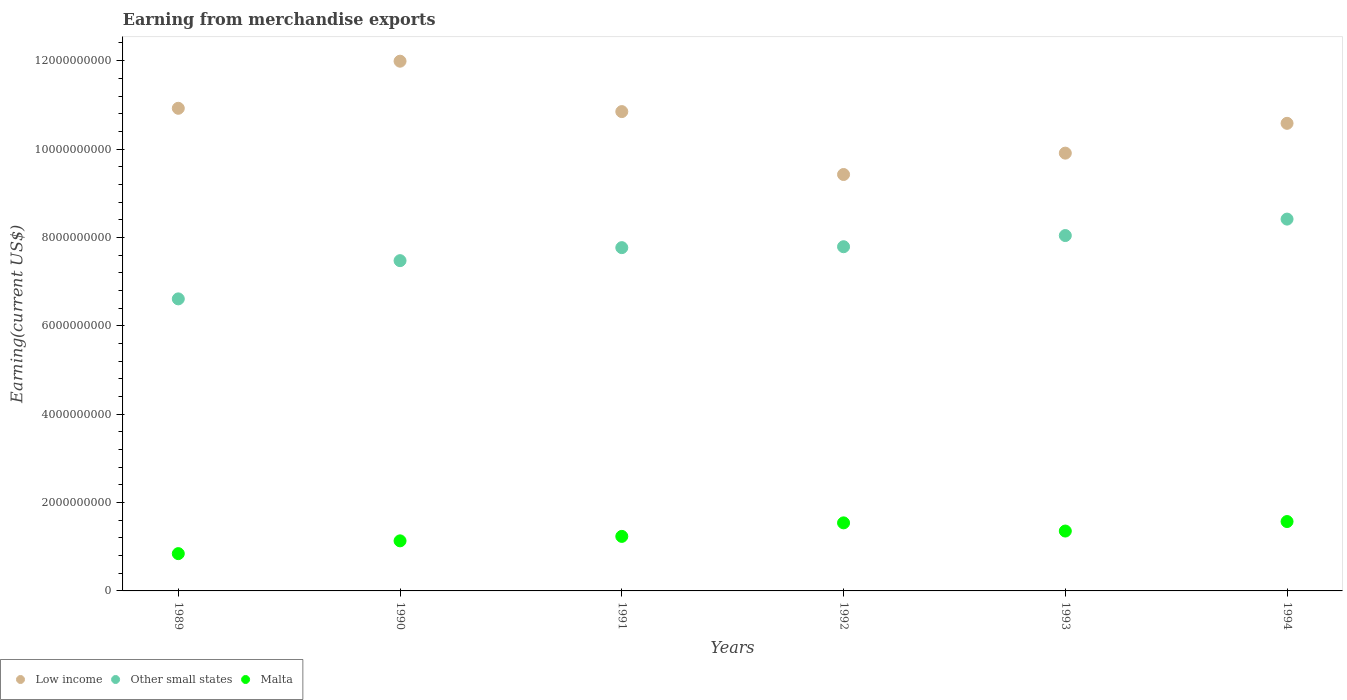How many different coloured dotlines are there?
Ensure brevity in your answer.  3. Is the number of dotlines equal to the number of legend labels?
Ensure brevity in your answer.  Yes. What is the amount earned from merchandise exports in Malta in 1989?
Offer a very short reply. 8.44e+08. Across all years, what is the maximum amount earned from merchandise exports in Low income?
Keep it short and to the point. 1.20e+1. Across all years, what is the minimum amount earned from merchandise exports in Malta?
Offer a terse response. 8.44e+08. In which year was the amount earned from merchandise exports in Malta maximum?
Your response must be concise. 1994. What is the total amount earned from merchandise exports in Malta in the graph?
Provide a succinct answer. 7.68e+09. What is the difference between the amount earned from merchandise exports in Low income in 1989 and that in 1994?
Your answer should be very brief. 3.40e+08. What is the difference between the amount earned from merchandise exports in Malta in 1991 and the amount earned from merchandise exports in Low income in 1992?
Offer a terse response. -8.19e+09. What is the average amount earned from merchandise exports in Other small states per year?
Give a very brief answer. 7.68e+09. In the year 1989, what is the difference between the amount earned from merchandise exports in Malta and amount earned from merchandise exports in Low income?
Give a very brief answer. -1.01e+1. What is the ratio of the amount earned from merchandise exports in Malta in 1992 to that in 1993?
Ensure brevity in your answer.  1.14. What is the difference between the highest and the second highest amount earned from merchandise exports in Malta?
Ensure brevity in your answer.  3.00e+07. What is the difference between the highest and the lowest amount earned from merchandise exports in Other small states?
Your response must be concise. 1.81e+09. Is it the case that in every year, the sum of the amount earned from merchandise exports in Malta and amount earned from merchandise exports in Other small states  is greater than the amount earned from merchandise exports in Low income?
Provide a succinct answer. No. Does the amount earned from merchandise exports in Other small states monotonically increase over the years?
Offer a very short reply. Yes. How many years are there in the graph?
Make the answer very short. 6. What is the difference between two consecutive major ticks on the Y-axis?
Provide a succinct answer. 2.00e+09. Does the graph contain any zero values?
Your response must be concise. No. Where does the legend appear in the graph?
Give a very brief answer. Bottom left. How many legend labels are there?
Make the answer very short. 3. What is the title of the graph?
Offer a very short reply. Earning from merchandise exports. What is the label or title of the X-axis?
Provide a short and direct response. Years. What is the label or title of the Y-axis?
Keep it short and to the point. Earning(current US$). What is the Earning(current US$) of Low income in 1989?
Your response must be concise. 1.09e+1. What is the Earning(current US$) in Other small states in 1989?
Your answer should be compact. 6.61e+09. What is the Earning(current US$) in Malta in 1989?
Make the answer very short. 8.44e+08. What is the Earning(current US$) of Low income in 1990?
Offer a terse response. 1.20e+1. What is the Earning(current US$) of Other small states in 1990?
Give a very brief answer. 7.47e+09. What is the Earning(current US$) of Malta in 1990?
Your answer should be compact. 1.13e+09. What is the Earning(current US$) in Low income in 1991?
Your answer should be compact. 1.08e+1. What is the Earning(current US$) of Other small states in 1991?
Provide a succinct answer. 7.77e+09. What is the Earning(current US$) of Malta in 1991?
Offer a very short reply. 1.23e+09. What is the Earning(current US$) in Low income in 1992?
Your answer should be compact. 9.42e+09. What is the Earning(current US$) in Other small states in 1992?
Offer a terse response. 7.79e+09. What is the Earning(current US$) in Malta in 1992?
Ensure brevity in your answer.  1.54e+09. What is the Earning(current US$) of Low income in 1993?
Your answer should be very brief. 9.91e+09. What is the Earning(current US$) in Other small states in 1993?
Your answer should be very brief. 8.04e+09. What is the Earning(current US$) in Malta in 1993?
Provide a short and direct response. 1.36e+09. What is the Earning(current US$) in Low income in 1994?
Your answer should be very brief. 1.06e+1. What is the Earning(current US$) of Other small states in 1994?
Offer a terse response. 8.41e+09. What is the Earning(current US$) of Malta in 1994?
Make the answer very short. 1.57e+09. Across all years, what is the maximum Earning(current US$) in Low income?
Offer a very short reply. 1.20e+1. Across all years, what is the maximum Earning(current US$) in Other small states?
Offer a terse response. 8.41e+09. Across all years, what is the maximum Earning(current US$) of Malta?
Offer a terse response. 1.57e+09. Across all years, what is the minimum Earning(current US$) of Low income?
Offer a very short reply. 9.42e+09. Across all years, what is the minimum Earning(current US$) of Other small states?
Provide a short and direct response. 6.61e+09. Across all years, what is the minimum Earning(current US$) of Malta?
Provide a short and direct response. 8.44e+08. What is the total Earning(current US$) in Low income in the graph?
Offer a very short reply. 6.37e+1. What is the total Earning(current US$) of Other small states in the graph?
Offer a terse response. 4.61e+1. What is the total Earning(current US$) in Malta in the graph?
Ensure brevity in your answer.  7.68e+09. What is the difference between the Earning(current US$) of Low income in 1989 and that in 1990?
Ensure brevity in your answer.  -1.07e+09. What is the difference between the Earning(current US$) of Other small states in 1989 and that in 1990?
Your answer should be compact. -8.65e+08. What is the difference between the Earning(current US$) in Malta in 1989 and that in 1990?
Provide a succinct answer. -2.89e+08. What is the difference between the Earning(current US$) in Low income in 1989 and that in 1991?
Offer a terse response. 7.49e+07. What is the difference between the Earning(current US$) of Other small states in 1989 and that in 1991?
Offer a terse response. -1.16e+09. What is the difference between the Earning(current US$) in Malta in 1989 and that in 1991?
Your response must be concise. -3.90e+08. What is the difference between the Earning(current US$) of Low income in 1989 and that in 1992?
Ensure brevity in your answer.  1.50e+09. What is the difference between the Earning(current US$) in Other small states in 1989 and that in 1992?
Offer a very short reply. -1.18e+09. What is the difference between the Earning(current US$) in Malta in 1989 and that in 1992?
Your answer should be very brief. -6.96e+08. What is the difference between the Earning(current US$) in Low income in 1989 and that in 1993?
Your answer should be compact. 1.01e+09. What is the difference between the Earning(current US$) in Other small states in 1989 and that in 1993?
Your response must be concise. -1.43e+09. What is the difference between the Earning(current US$) of Malta in 1989 and that in 1993?
Provide a succinct answer. -5.11e+08. What is the difference between the Earning(current US$) of Low income in 1989 and that in 1994?
Offer a very short reply. 3.40e+08. What is the difference between the Earning(current US$) in Other small states in 1989 and that in 1994?
Offer a terse response. -1.81e+09. What is the difference between the Earning(current US$) in Malta in 1989 and that in 1994?
Ensure brevity in your answer.  -7.26e+08. What is the difference between the Earning(current US$) of Low income in 1990 and that in 1991?
Provide a succinct answer. 1.14e+09. What is the difference between the Earning(current US$) in Other small states in 1990 and that in 1991?
Offer a very short reply. -2.94e+08. What is the difference between the Earning(current US$) in Malta in 1990 and that in 1991?
Provide a succinct answer. -1.01e+08. What is the difference between the Earning(current US$) of Low income in 1990 and that in 1992?
Your answer should be compact. 2.56e+09. What is the difference between the Earning(current US$) in Other small states in 1990 and that in 1992?
Your answer should be compact. -3.15e+08. What is the difference between the Earning(current US$) of Malta in 1990 and that in 1992?
Your answer should be very brief. -4.07e+08. What is the difference between the Earning(current US$) of Low income in 1990 and that in 1993?
Offer a very short reply. 2.08e+09. What is the difference between the Earning(current US$) in Other small states in 1990 and that in 1993?
Make the answer very short. -5.68e+08. What is the difference between the Earning(current US$) of Malta in 1990 and that in 1993?
Ensure brevity in your answer.  -2.22e+08. What is the difference between the Earning(current US$) in Low income in 1990 and that in 1994?
Make the answer very short. 1.41e+09. What is the difference between the Earning(current US$) in Other small states in 1990 and that in 1994?
Provide a succinct answer. -9.40e+08. What is the difference between the Earning(current US$) of Malta in 1990 and that in 1994?
Provide a short and direct response. -4.37e+08. What is the difference between the Earning(current US$) of Low income in 1991 and that in 1992?
Offer a very short reply. 1.42e+09. What is the difference between the Earning(current US$) of Other small states in 1991 and that in 1992?
Make the answer very short. -2.07e+07. What is the difference between the Earning(current US$) of Malta in 1991 and that in 1992?
Keep it short and to the point. -3.06e+08. What is the difference between the Earning(current US$) of Low income in 1991 and that in 1993?
Give a very brief answer. 9.40e+08. What is the difference between the Earning(current US$) of Other small states in 1991 and that in 1993?
Provide a short and direct response. -2.73e+08. What is the difference between the Earning(current US$) of Malta in 1991 and that in 1993?
Offer a very short reply. -1.21e+08. What is the difference between the Earning(current US$) in Low income in 1991 and that in 1994?
Provide a short and direct response. 2.65e+08. What is the difference between the Earning(current US$) of Other small states in 1991 and that in 1994?
Ensure brevity in your answer.  -6.46e+08. What is the difference between the Earning(current US$) in Malta in 1991 and that in 1994?
Provide a succinct answer. -3.36e+08. What is the difference between the Earning(current US$) in Low income in 1992 and that in 1993?
Provide a short and direct response. -4.84e+08. What is the difference between the Earning(current US$) in Other small states in 1992 and that in 1993?
Offer a terse response. -2.53e+08. What is the difference between the Earning(current US$) in Malta in 1992 and that in 1993?
Make the answer very short. 1.85e+08. What is the difference between the Earning(current US$) in Low income in 1992 and that in 1994?
Offer a terse response. -1.16e+09. What is the difference between the Earning(current US$) in Other small states in 1992 and that in 1994?
Keep it short and to the point. -6.25e+08. What is the difference between the Earning(current US$) in Malta in 1992 and that in 1994?
Offer a very short reply. -3.00e+07. What is the difference between the Earning(current US$) of Low income in 1993 and that in 1994?
Keep it short and to the point. -6.75e+08. What is the difference between the Earning(current US$) of Other small states in 1993 and that in 1994?
Provide a succinct answer. -3.72e+08. What is the difference between the Earning(current US$) in Malta in 1993 and that in 1994?
Offer a terse response. -2.15e+08. What is the difference between the Earning(current US$) in Low income in 1989 and the Earning(current US$) in Other small states in 1990?
Provide a succinct answer. 3.45e+09. What is the difference between the Earning(current US$) in Low income in 1989 and the Earning(current US$) in Malta in 1990?
Provide a short and direct response. 9.79e+09. What is the difference between the Earning(current US$) of Other small states in 1989 and the Earning(current US$) of Malta in 1990?
Give a very brief answer. 5.48e+09. What is the difference between the Earning(current US$) in Low income in 1989 and the Earning(current US$) in Other small states in 1991?
Provide a succinct answer. 3.15e+09. What is the difference between the Earning(current US$) in Low income in 1989 and the Earning(current US$) in Malta in 1991?
Offer a very short reply. 9.69e+09. What is the difference between the Earning(current US$) of Other small states in 1989 and the Earning(current US$) of Malta in 1991?
Make the answer very short. 5.38e+09. What is the difference between the Earning(current US$) in Low income in 1989 and the Earning(current US$) in Other small states in 1992?
Keep it short and to the point. 3.13e+09. What is the difference between the Earning(current US$) in Low income in 1989 and the Earning(current US$) in Malta in 1992?
Your response must be concise. 9.38e+09. What is the difference between the Earning(current US$) in Other small states in 1989 and the Earning(current US$) in Malta in 1992?
Give a very brief answer. 5.07e+09. What is the difference between the Earning(current US$) in Low income in 1989 and the Earning(current US$) in Other small states in 1993?
Provide a short and direct response. 2.88e+09. What is the difference between the Earning(current US$) in Low income in 1989 and the Earning(current US$) in Malta in 1993?
Provide a short and direct response. 9.57e+09. What is the difference between the Earning(current US$) in Other small states in 1989 and the Earning(current US$) in Malta in 1993?
Keep it short and to the point. 5.25e+09. What is the difference between the Earning(current US$) of Low income in 1989 and the Earning(current US$) of Other small states in 1994?
Your answer should be very brief. 2.51e+09. What is the difference between the Earning(current US$) in Low income in 1989 and the Earning(current US$) in Malta in 1994?
Your response must be concise. 9.35e+09. What is the difference between the Earning(current US$) in Other small states in 1989 and the Earning(current US$) in Malta in 1994?
Your response must be concise. 5.04e+09. What is the difference between the Earning(current US$) in Low income in 1990 and the Earning(current US$) in Other small states in 1991?
Your answer should be very brief. 4.22e+09. What is the difference between the Earning(current US$) of Low income in 1990 and the Earning(current US$) of Malta in 1991?
Provide a succinct answer. 1.08e+1. What is the difference between the Earning(current US$) in Other small states in 1990 and the Earning(current US$) in Malta in 1991?
Provide a short and direct response. 6.24e+09. What is the difference between the Earning(current US$) of Low income in 1990 and the Earning(current US$) of Other small states in 1992?
Your answer should be compact. 4.20e+09. What is the difference between the Earning(current US$) of Low income in 1990 and the Earning(current US$) of Malta in 1992?
Make the answer very short. 1.04e+1. What is the difference between the Earning(current US$) of Other small states in 1990 and the Earning(current US$) of Malta in 1992?
Your answer should be compact. 5.93e+09. What is the difference between the Earning(current US$) of Low income in 1990 and the Earning(current US$) of Other small states in 1993?
Your response must be concise. 3.95e+09. What is the difference between the Earning(current US$) of Low income in 1990 and the Earning(current US$) of Malta in 1993?
Your response must be concise. 1.06e+1. What is the difference between the Earning(current US$) in Other small states in 1990 and the Earning(current US$) in Malta in 1993?
Offer a terse response. 6.12e+09. What is the difference between the Earning(current US$) in Low income in 1990 and the Earning(current US$) in Other small states in 1994?
Keep it short and to the point. 3.57e+09. What is the difference between the Earning(current US$) of Low income in 1990 and the Earning(current US$) of Malta in 1994?
Offer a terse response. 1.04e+1. What is the difference between the Earning(current US$) in Other small states in 1990 and the Earning(current US$) in Malta in 1994?
Make the answer very short. 5.90e+09. What is the difference between the Earning(current US$) in Low income in 1991 and the Earning(current US$) in Other small states in 1992?
Offer a terse response. 3.06e+09. What is the difference between the Earning(current US$) in Low income in 1991 and the Earning(current US$) in Malta in 1992?
Provide a succinct answer. 9.31e+09. What is the difference between the Earning(current US$) in Other small states in 1991 and the Earning(current US$) in Malta in 1992?
Offer a terse response. 6.23e+09. What is the difference between the Earning(current US$) of Low income in 1991 and the Earning(current US$) of Other small states in 1993?
Offer a terse response. 2.81e+09. What is the difference between the Earning(current US$) of Low income in 1991 and the Earning(current US$) of Malta in 1993?
Provide a succinct answer. 9.49e+09. What is the difference between the Earning(current US$) of Other small states in 1991 and the Earning(current US$) of Malta in 1993?
Keep it short and to the point. 6.41e+09. What is the difference between the Earning(current US$) of Low income in 1991 and the Earning(current US$) of Other small states in 1994?
Offer a terse response. 2.43e+09. What is the difference between the Earning(current US$) in Low income in 1991 and the Earning(current US$) in Malta in 1994?
Keep it short and to the point. 9.28e+09. What is the difference between the Earning(current US$) in Other small states in 1991 and the Earning(current US$) in Malta in 1994?
Make the answer very short. 6.20e+09. What is the difference between the Earning(current US$) in Low income in 1992 and the Earning(current US$) in Other small states in 1993?
Offer a terse response. 1.38e+09. What is the difference between the Earning(current US$) in Low income in 1992 and the Earning(current US$) in Malta in 1993?
Make the answer very short. 8.07e+09. What is the difference between the Earning(current US$) of Other small states in 1992 and the Earning(current US$) of Malta in 1993?
Provide a succinct answer. 6.43e+09. What is the difference between the Earning(current US$) of Low income in 1992 and the Earning(current US$) of Other small states in 1994?
Provide a succinct answer. 1.01e+09. What is the difference between the Earning(current US$) in Low income in 1992 and the Earning(current US$) in Malta in 1994?
Make the answer very short. 7.85e+09. What is the difference between the Earning(current US$) of Other small states in 1992 and the Earning(current US$) of Malta in 1994?
Provide a succinct answer. 6.22e+09. What is the difference between the Earning(current US$) in Low income in 1993 and the Earning(current US$) in Other small states in 1994?
Keep it short and to the point. 1.49e+09. What is the difference between the Earning(current US$) in Low income in 1993 and the Earning(current US$) in Malta in 1994?
Keep it short and to the point. 8.34e+09. What is the difference between the Earning(current US$) in Other small states in 1993 and the Earning(current US$) in Malta in 1994?
Your answer should be very brief. 6.47e+09. What is the average Earning(current US$) in Low income per year?
Your response must be concise. 1.06e+1. What is the average Earning(current US$) of Other small states per year?
Make the answer very short. 7.68e+09. What is the average Earning(current US$) of Malta per year?
Keep it short and to the point. 1.28e+09. In the year 1989, what is the difference between the Earning(current US$) in Low income and Earning(current US$) in Other small states?
Your response must be concise. 4.31e+09. In the year 1989, what is the difference between the Earning(current US$) of Low income and Earning(current US$) of Malta?
Offer a very short reply. 1.01e+1. In the year 1989, what is the difference between the Earning(current US$) in Other small states and Earning(current US$) in Malta?
Offer a very short reply. 5.77e+09. In the year 1990, what is the difference between the Earning(current US$) in Low income and Earning(current US$) in Other small states?
Ensure brevity in your answer.  4.51e+09. In the year 1990, what is the difference between the Earning(current US$) of Low income and Earning(current US$) of Malta?
Give a very brief answer. 1.09e+1. In the year 1990, what is the difference between the Earning(current US$) of Other small states and Earning(current US$) of Malta?
Provide a succinct answer. 6.34e+09. In the year 1991, what is the difference between the Earning(current US$) in Low income and Earning(current US$) in Other small states?
Make the answer very short. 3.08e+09. In the year 1991, what is the difference between the Earning(current US$) of Low income and Earning(current US$) of Malta?
Ensure brevity in your answer.  9.61e+09. In the year 1991, what is the difference between the Earning(current US$) in Other small states and Earning(current US$) in Malta?
Make the answer very short. 6.53e+09. In the year 1992, what is the difference between the Earning(current US$) in Low income and Earning(current US$) in Other small states?
Your answer should be very brief. 1.63e+09. In the year 1992, what is the difference between the Earning(current US$) of Low income and Earning(current US$) of Malta?
Keep it short and to the point. 7.88e+09. In the year 1992, what is the difference between the Earning(current US$) in Other small states and Earning(current US$) in Malta?
Your answer should be compact. 6.25e+09. In the year 1993, what is the difference between the Earning(current US$) of Low income and Earning(current US$) of Other small states?
Offer a very short reply. 1.87e+09. In the year 1993, what is the difference between the Earning(current US$) in Low income and Earning(current US$) in Malta?
Your response must be concise. 8.55e+09. In the year 1993, what is the difference between the Earning(current US$) in Other small states and Earning(current US$) in Malta?
Give a very brief answer. 6.69e+09. In the year 1994, what is the difference between the Earning(current US$) of Low income and Earning(current US$) of Other small states?
Provide a short and direct response. 2.17e+09. In the year 1994, what is the difference between the Earning(current US$) in Low income and Earning(current US$) in Malta?
Provide a succinct answer. 9.01e+09. In the year 1994, what is the difference between the Earning(current US$) in Other small states and Earning(current US$) in Malta?
Offer a very short reply. 6.84e+09. What is the ratio of the Earning(current US$) of Low income in 1989 to that in 1990?
Your answer should be compact. 0.91. What is the ratio of the Earning(current US$) of Other small states in 1989 to that in 1990?
Your answer should be very brief. 0.88. What is the ratio of the Earning(current US$) of Malta in 1989 to that in 1990?
Your answer should be compact. 0.74. What is the ratio of the Earning(current US$) of Low income in 1989 to that in 1991?
Your answer should be very brief. 1.01. What is the ratio of the Earning(current US$) in Other small states in 1989 to that in 1991?
Your response must be concise. 0.85. What is the ratio of the Earning(current US$) in Malta in 1989 to that in 1991?
Your response must be concise. 0.68. What is the ratio of the Earning(current US$) of Low income in 1989 to that in 1992?
Your answer should be very brief. 1.16. What is the ratio of the Earning(current US$) of Other small states in 1989 to that in 1992?
Your response must be concise. 0.85. What is the ratio of the Earning(current US$) of Malta in 1989 to that in 1992?
Give a very brief answer. 0.55. What is the ratio of the Earning(current US$) of Low income in 1989 to that in 1993?
Ensure brevity in your answer.  1.1. What is the ratio of the Earning(current US$) in Other small states in 1989 to that in 1993?
Provide a succinct answer. 0.82. What is the ratio of the Earning(current US$) in Malta in 1989 to that in 1993?
Provide a short and direct response. 0.62. What is the ratio of the Earning(current US$) in Low income in 1989 to that in 1994?
Give a very brief answer. 1.03. What is the ratio of the Earning(current US$) of Other small states in 1989 to that in 1994?
Offer a terse response. 0.79. What is the ratio of the Earning(current US$) of Malta in 1989 to that in 1994?
Ensure brevity in your answer.  0.54. What is the ratio of the Earning(current US$) of Low income in 1990 to that in 1991?
Provide a short and direct response. 1.11. What is the ratio of the Earning(current US$) of Other small states in 1990 to that in 1991?
Give a very brief answer. 0.96. What is the ratio of the Earning(current US$) of Malta in 1990 to that in 1991?
Your answer should be compact. 0.92. What is the ratio of the Earning(current US$) of Low income in 1990 to that in 1992?
Your answer should be compact. 1.27. What is the ratio of the Earning(current US$) of Other small states in 1990 to that in 1992?
Offer a very short reply. 0.96. What is the ratio of the Earning(current US$) of Malta in 1990 to that in 1992?
Your answer should be compact. 0.74. What is the ratio of the Earning(current US$) of Low income in 1990 to that in 1993?
Your answer should be compact. 1.21. What is the ratio of the Earning(current US$) of Other small states in 1990 to that in 1993?
Provide a short and direct response. 0.93. What is the ratio of the Earning(current US$) of Malta in 1990 to that in 1993?
Ensure brevity in your answer.  0.84. What is the ratio of the Earning(current US$) in Low income in 1990 to that in 1994?
Your answer should be very brief. 1.13. What is the ratio of the Earning(current US$) of Other small states in 1990 to that in 1994?
Provide a short and direct response. 0.89. What is the ratio of the Earning(current US$) of Malta in 1990 to that in 1994?
Offer a terse response. 0.72. What is the ratio of the Earning(current US$) of Low income in 1991 to that in 1992?
Your answer should be compact. 1.15. What is the ratio of the Earning(current US$) of Other small states in 1991 to that in 1992?
Your answer should be very brief. 1. What is the ratio of the Earning(current US$) of Malta in 1991 to that in 1992?
Keep it short and to the point. 0.8. What is the ratio of the Earning(current US$) of Low income in 1991 to that in 1993?
Your answer should be very brief. 1.09. What is the ratio of the Earning(current US$) of Malta in 1991 to that in 1993?
Keep it short and to the point. 0.91. What is the ratio of the Earning(current US$) in Low income in 1991 to that in 1994?
Your answer should be very brief. 1.03. What is the ratio of the Earning(current US$) of Other small states in 1991 to that in 1994?
Ensure brevity in your answer.  0.92. What is the ratio of the Earning(current US$) of Malta in 1991 to that in 1994?
Keep it short and to the point. 0.79. What is the ratio of the Earning(current US$) of Low income in 1992 to that in 1993?
Your response must be concise. 0.95. What is the ratio of the Earning(current US$) of Other small states in 1992 to that in 1993?
Provide a short and direct response. 0.97. What is the ratio of the Earning(current US$) in Malta in 1992 to that in 1993?
Provide a short and direct response. 1.14. What is the ratio of the Earning(current US$) of Low income in 1992 to that in 1994?
Your answer should be compact. 0.89. What is the ratio of the Earning(current US$) of Other small states in 1992 to that in 1994?
Make the answer very short. 0.93. What is the ratio of the Earning(current US$) in Malta in 1992 to that in 1994?
Your response must be concise. 0.98. What is the ratio of the Earning(current US$) in Low income in 1993 to that in 1994?
Ensure brevity in your answer.  0.94. What is the ratio of the Earning(current US$) of Other small states in 1993 to that in 1994?
Provide a succinct answer. 0.96. What is the ratio of the Earning(current US$) of Malta in 1993 to that in 1994?
Your response must be concise. 0.86. What is the difference between the highest and the second highest Earning(current US$) of Low income?
Your answer should be compact. 1.07e+09. What is the difference between the highest and the second highest Earning(current US$) in Other small states?
Your answer should be compact. 3.72e+08. What is the difference between the highest and the second highest Earning(current US$) in Malta?
Provide a succinct answer. 3.00e+07. What is the difference between the highest and the lowest Earning(current US$) of Low income?
Your answer should be compact. 2.56e+09. What is the difference between the highest and the lowest Earning(current US$) of Other small states?
Your answer should be compact. 1.81e+09. What is the difference between the highest and the lowest Earning(current US$) of Malta?
Your response must be concise. 7.26e+08. 